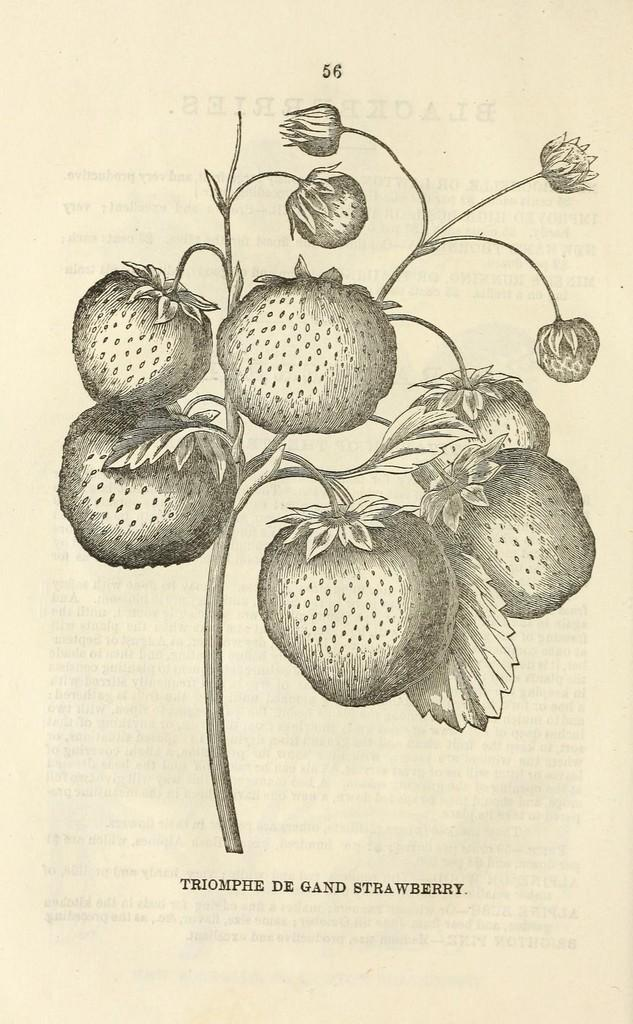What is depicted on the poster in the image? The poster contains a sketch of flowers and fruits. What type of artwork is featured on the poster? The artwork on the poster is a sketch. What type of teeth can be seen on the pig in the image? There is no pig or teeth present in the image; the poster contains sketches of flowers and fruits. 